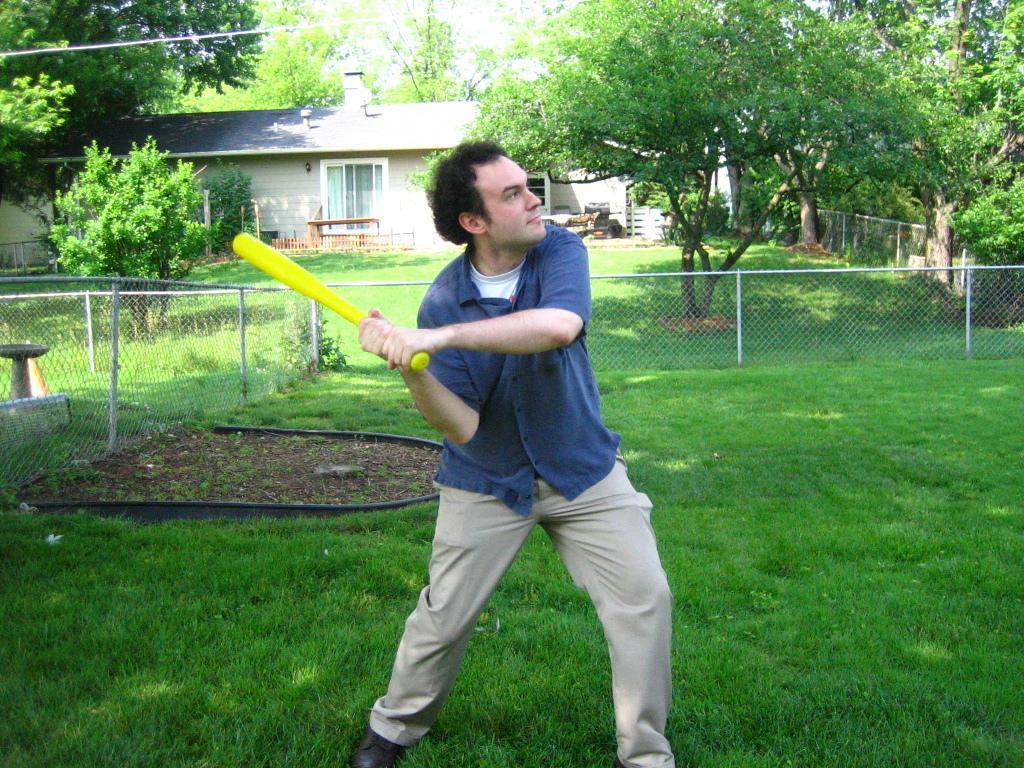How would you summarize this image in a sentence or two? In this image we can see a person wearing blue color shirt, cream color pant, holding yellow color baseball stick in his hands and at the background of the image there is fencing, house and there are some trees. 